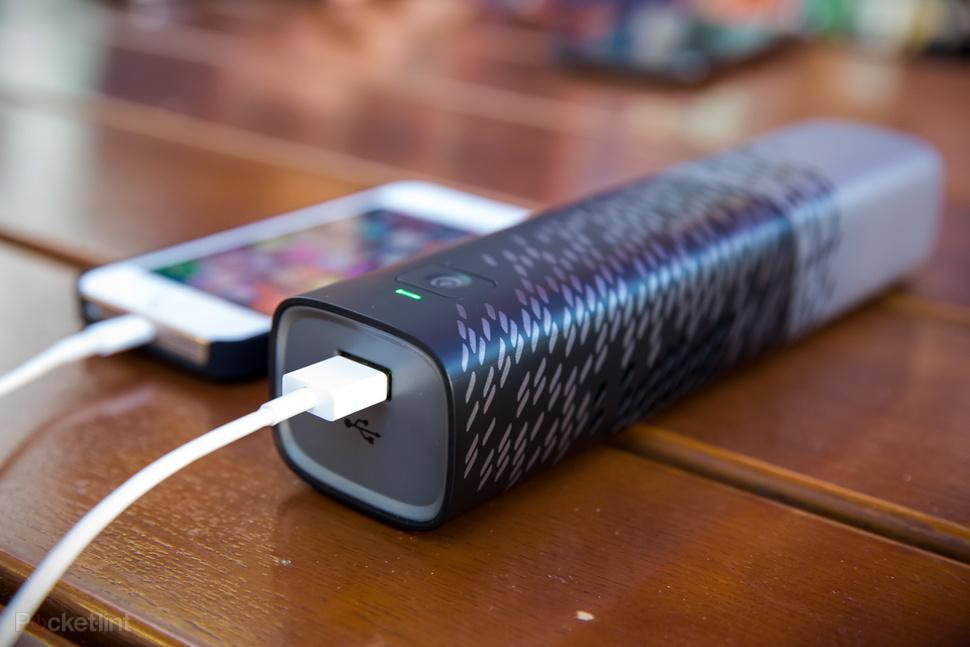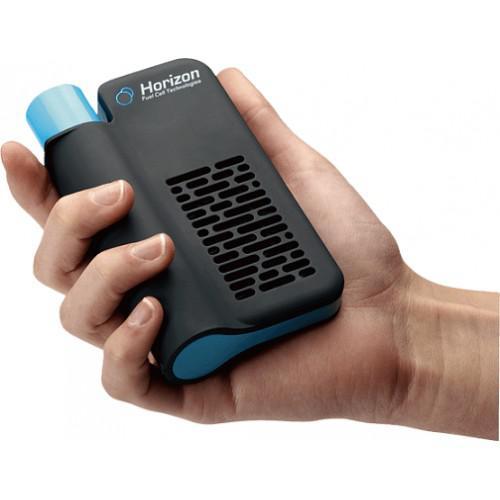The first image is the image on the left, the second image is the image on the right. For the images shown, is this caption "The right image shows a flat rectangular device with a cord in it, next to a charging device with the other end of the cord in it." true? Answer yes or no. No. The first image is the image on the left, the second image is the image on the right. For the images displayed, is the sentence "There are three devices." factually correct? Answer yes or no. Yes. 